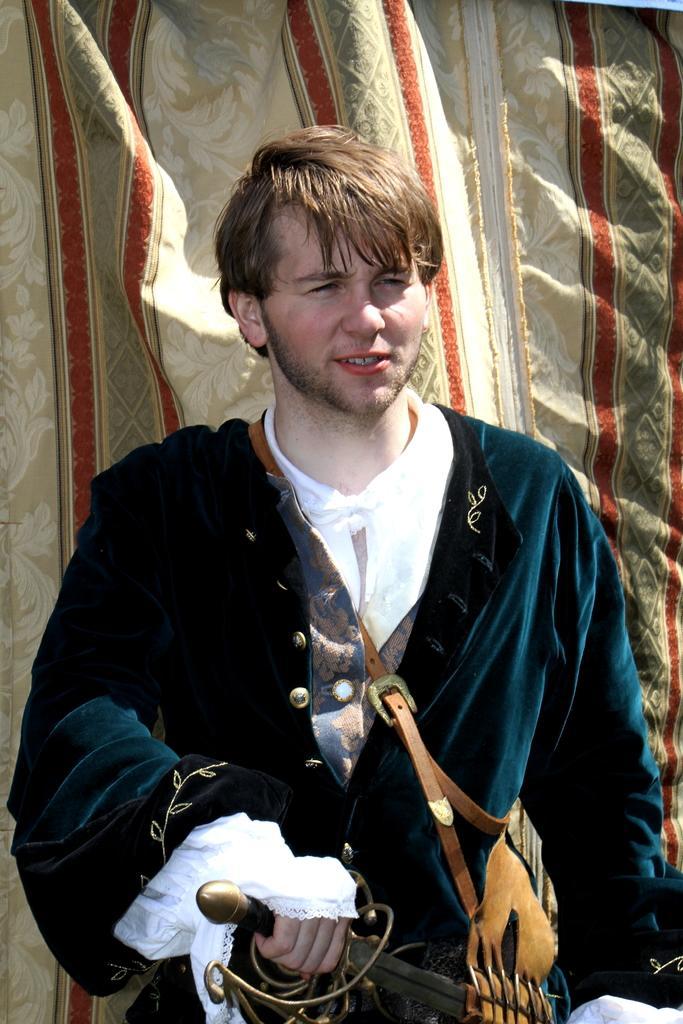In one or two sentences, can you explain what this image depicts? There is one person standing and wearing a blue color coat and holding a sword in the middle of this image. There is a curtain in the background. 